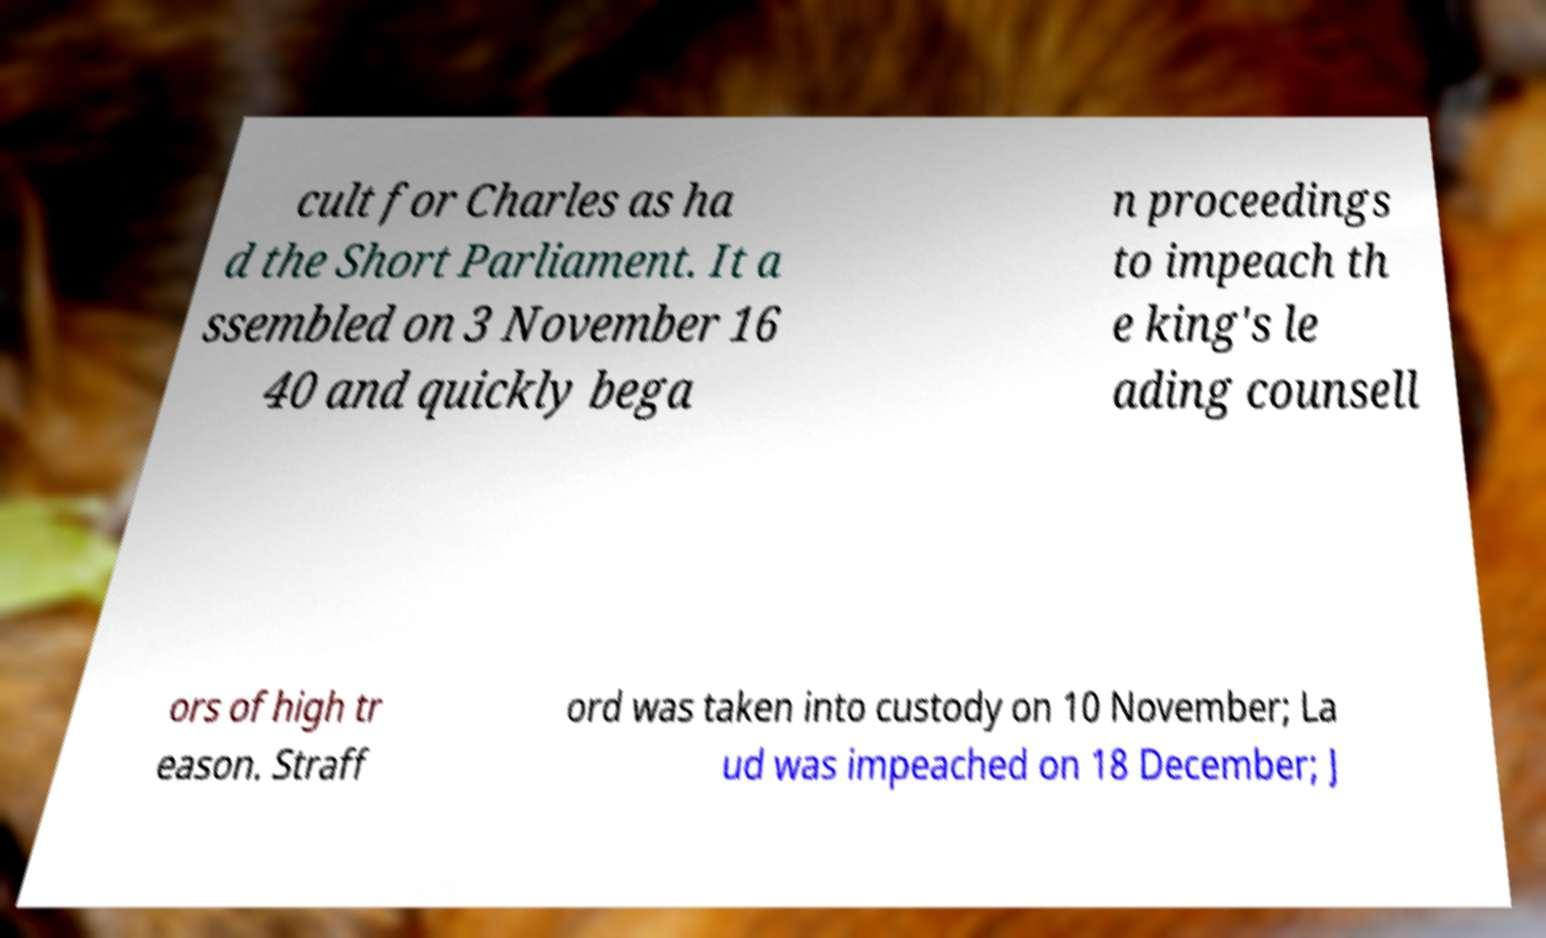Please read and relay the text visible in this image. What does it say? cult for Charles as ha d the Short Parliament. It a ssembled on 3 November 16 40 and quickly bega n proceedings to impeach th e king's le ading counsell ors of high tr eason. Straff ord was taken into custody on 10 November; La ud was impeached on 18 December; J 